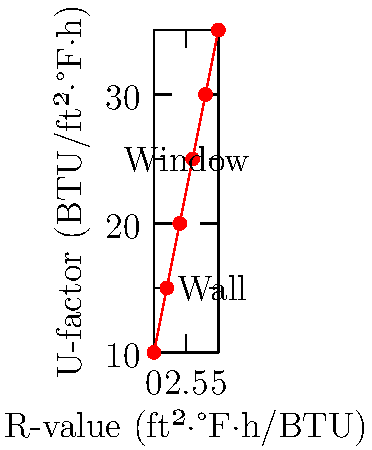Based on the graph showing the relationship between R-values and U-factors for different house components, calculate the total heat loss through a 200 ft² wall with an R-value of 13 and a 50 ft² window with a U-factor of 0.3, given an indoor temperature of 70°F and an outdoor temperature of 30°F. To solve this problem, we'll follow these steps:

1. Convert R-value to U-factor for the wall:
   $U_{wall} = \frac{1}{R} = \frac{1}{13} = 0.0769$ BTU/ft²·°F·h

2. Calculate heat loss through the wall:
   $Q_{wall} = U_{wall} \times A_{wall} \times \Delta T$
   $Q_{wall} = 0.0769 \times 200 \times (70 - 30) = 615.2$ BTU/h

3. Calculate heat loss through the window:
   $Q_{window} = U_{window} \times A_{window} \times \Delta T$
   $Q_{window} = 0.3 \times 50 \times (70 - 30) = 600$ BTU/h

4. Calculate total heat loss:
   $Q_{total} = Q_{wall} + Q_{window}$
   $Q_{total} = 615.2 + 600 = 1215.2$ BTU/h
Answer: 1215.2 BTU/h 